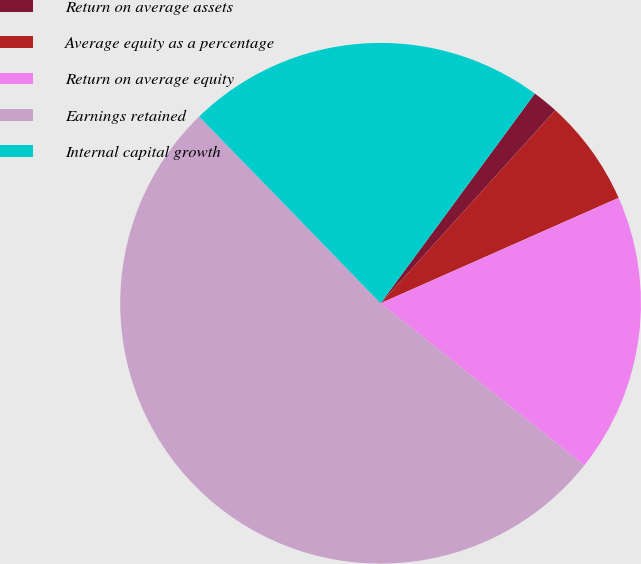Convert chart. <chart><loc_0><loc_0><loc_500><loc_500><pie_chart><fcel>Return on average assets<fcel>Average equity as a percentage<fcel>Return on average equity<fcel>Earnings retained<fcel>Internal capital growth<nl><fcel>1.61%<fcel>6.66%<fcel>17.33%<fcel>52.03%<fcel>22.37%<nl></chart> 